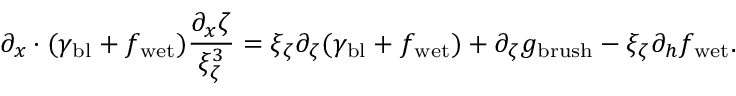<formula> <loc_0><loc_0><loc_500><loc_500>\partial _ { x } \cdot ( \gamma _ { b l } + f _ { w e t } ) \frac { \partial _ { x } \zeta } { \xi _ { \zeta } ^ { 3 } } = \xi _ { \zeta } \partial _ { \zeta } ( \gamma _ { b l } + f _ { w e t } ) + \partial _ { \zeta } g _ { b r u s h } - \xi _ { \zeta } \partial _ { h } f _ { w e t } .</formula> 